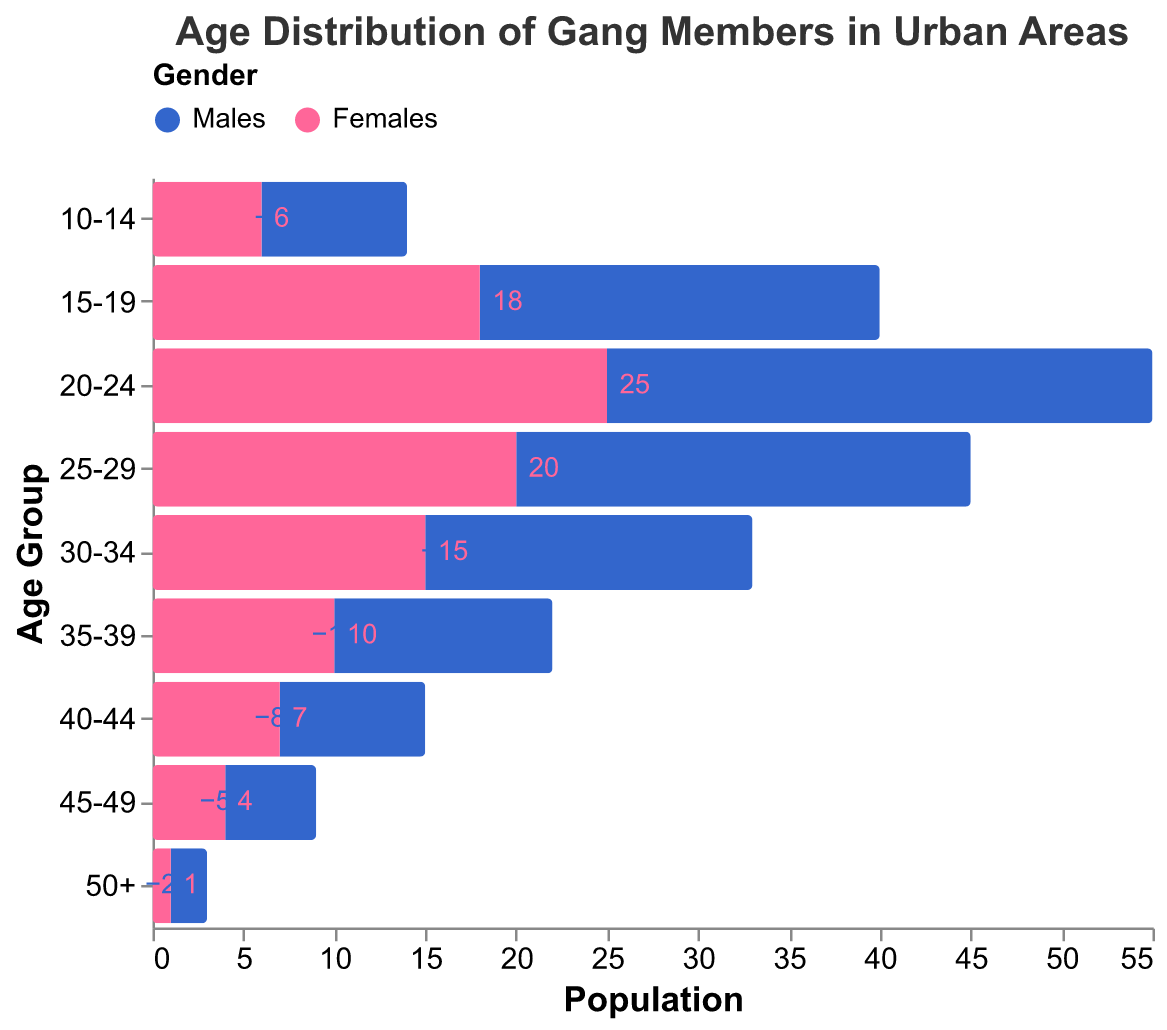What's the title of the figure? The title is usually found at the top of the figure.
Answer: Age Distribution of Gang Members in Urban Areas How many age groups are displayed in the figure? Count the unique entries in the y-axis, which correspond to distinct age groups.
Answer: 9 Which gender has the highest count in the 20-24 age group? Compare the values for males and females in the 20-24 age group.
Answer: Females What is the difference in the count of gang members between males and females in the 15-19 age group? Subtract the count of females from males in the 15-19 age group, considering the male value is negative. Calculation: 22 (females) - 18 (males) = 4.
Answer: 4 In which age group do males have the lowest count? Look for the age group with the smallest (most negative) value in the "Males" column.
Answer: 50+ What's the combined total count of males and females in the 25-29 age group? Add the absolute values of males and females in the 25-29 age group. Calculation: 25 (males) + 20 (females) = 45.
Answer: 45 How does the count of females in the 35-39 age group compare to that in the 40-44 age group? Compare the values directly.
Answer: The 35-39 age group has more females than the 40-44 age group Which gender forms a larger portion of the juvenile age group (10-14)? Compare the counts of males and females in the 10-14 age group.
Answer: Females What trend do you observe in the population of gang members as they age from 10-14 to 50+ for males? Notice how the values for males decrease as age increases.
Answer: Declining trend In which age group is the gender disparity (difference between male and female counts) the greatest? Calculate the absolute differences between male and female counts for each age group. The largest difference will determine the most significant disparity.
Answer: 20-24 